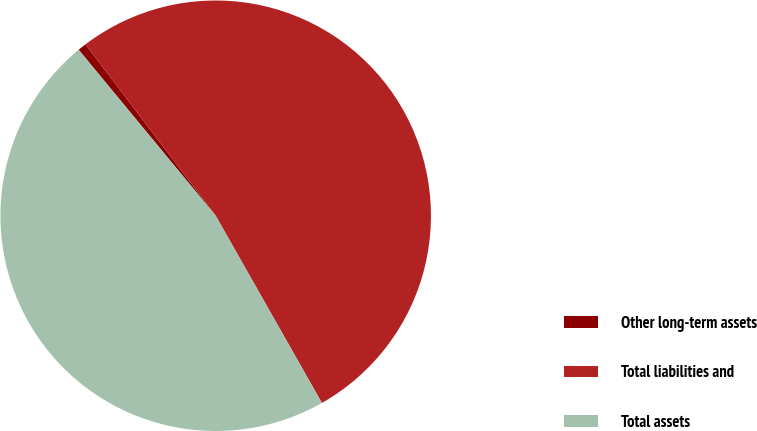Convert chart. <chart><loc_0><loc_0><loc_500><loc_500><pie_chart><fcel>Other long-term assets<fcel>Total liabilities and<fcel>Total assets<nl><fcel>0.64%<fcel>52.13%<fcel>47.23%<nl></chart> 